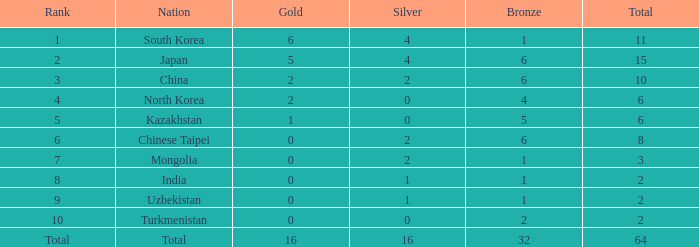How many golds did the 10th position obtain, with a bronze greater than 2? 0.0. 